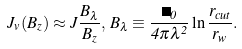<formula> <loc_0><loc_0><loc_500><loc_500>J _ { v } ( B _ { z } ) \approx J \frac { B _ { \lambda } } { B _ { z } } , \, B _ { \lambda } \equiv \frac { \Phi _ { 0 } } { 4 \pi \lambda ^ { 2 } } \ln \frac { r _ { c u t } } { r _ { w } } .</formula> 